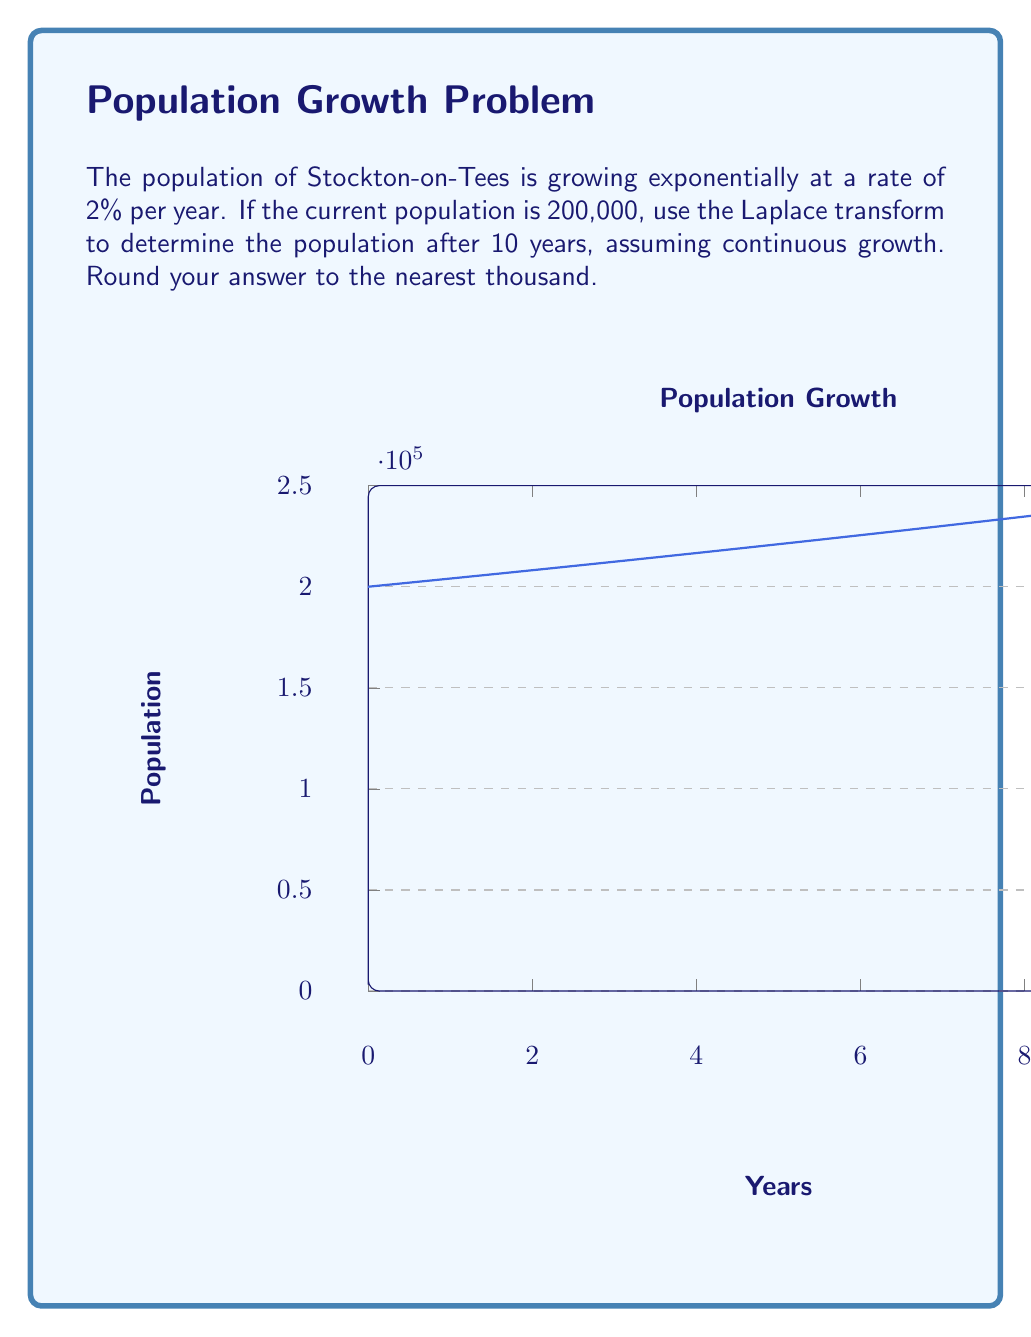Teach me how to tackle this problem. Let's approach this step-by-step using Laplace transforms:

1) The population growth model is given by the differential equation:
   $$\frac{dP}{dt} = 0.02P$$
   where $P$ is the population and $t$ is time in years.

2) The initial condition is $P(0) = 200,000$.

3) Taking the Laplace transform of both sides:
   $$\mathcal{L}\left\{\frac{dP}{dt}\right\} = 0.02\mathcal{L}\{P\}$$

4) Using the property of Laplace transform for derivatives:
   $$sP(s) - P(0) = 0.02P(s)$$

5) Substituting the initial condition:
   $$sP(s) - 200,000 = 0.02P(s)$$

6) Solving for $P(s)$:
   $$P(s) = \frac{200,000}{s - 0.02}$$

7) The inverse Laplace transform of this is:
   $$P(t) = 200,000e^{0.02t}$$

8) To find the population after 10 years, we substitute $t = 10$:
   $$P(10) = 200,000e^{0.02 * 10} = 200,000e^{0.2} \approx 244,281$$

9) Rounding to the nearest thousand:
   $$P(10) \approx 244,000$$
Answer: 244,000 